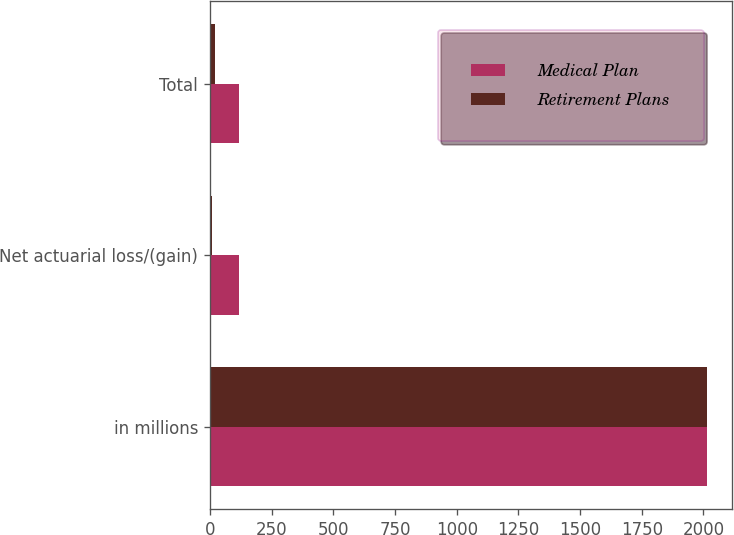Convert chart. <chart><loc_0><loc_0><loc_500><loc_500><stacked_bar_chart><ecel><fcel>in millions<fcel>Net actuarial loss/(gain)<fcel>Total<nl><fcel>Medical Plan<fcel>2015<fcel>118.2<fcel>118.2<nl><fcel>Retirement Plans<fcel>2015<fcel>8.4<fcel>19.7<nl></chart> 